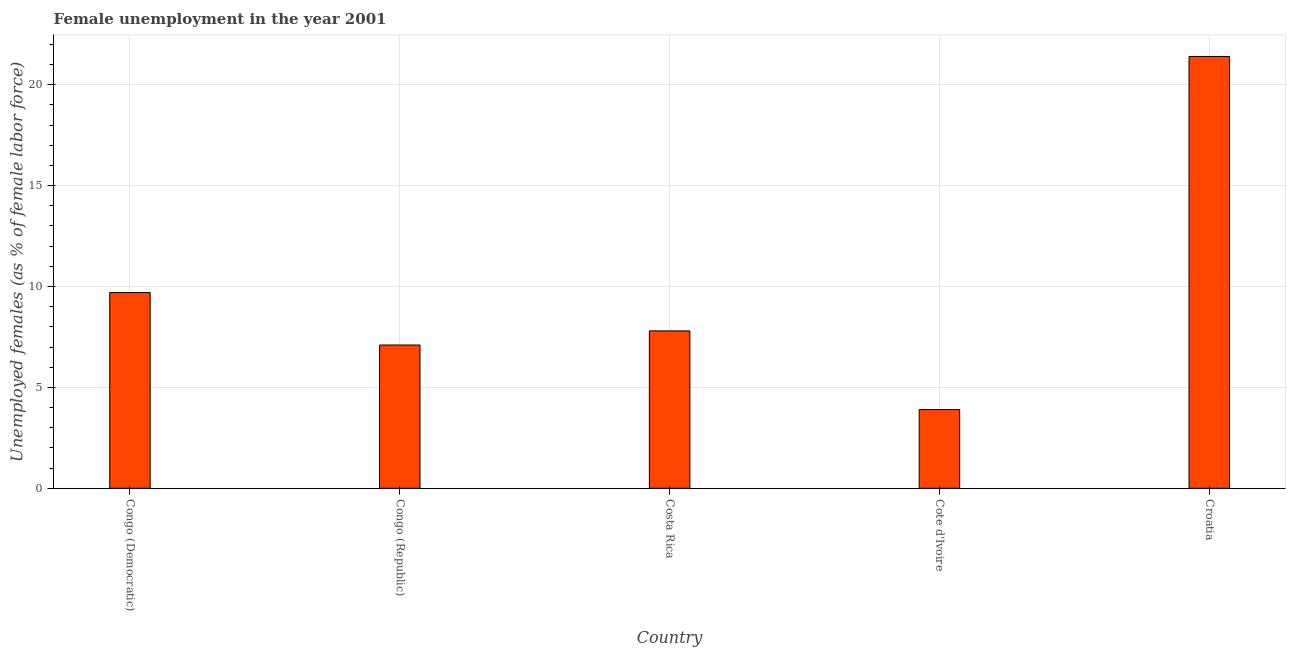What is the title of the graph?
Offer a terse response. Female unemployment in the year 2001. What is the label or title of the Y-axis?
Provide a short and direct response. Unemployed females (as % of female labor force). What is the unemployed females population in Cote d'Ivoire?
Provide a short and direct response. 3.9. Across all countries, what is the maximum unemployed females population?
Your response must be concise. 21.4. Across all countries, what is the minimum unemployed females population?
Your answer should be compact. 3.9. In which country was the unemployed females population maximum?
Offer a very short reply. Croatia. In which country was the unemployed females population minimum?
Ensure brevity in your answer.  Cote d'Ivoire. What is the sum of the unemployed females population?
Your answer should be compact. 49.9. What is the average unemployed females population per country?
Ensure brevity in your answer.  9.98. What is the median unemployed females population?
Your response must be concise. 7.8. In how many countries, is the unemployed females population greater than 14 %?
Make the answer very short. 1. What is the ratio of the unemployed females population in Congo (Republic) to that in Cote d'Ivoire?
Your answer should be very brief. 1.82. Is the unemployed females population in Congo (Democratic) less than that in Cote d'Ivoire?
Keep it short and to the point. No. Is the sum of the unemployed females population in Congo (Republic) and Costa Rica greater than the maximum unemployed females population across all countries?
Keep it short and to the point. No. How many bars are there?
Provide a succinct answer. 5. Are all the bars in the graph horizontal?
Your answer should be very brief. No. Are the values on the major ticks of Y-axis written in scientific E-notation?
Offer a very short reply. No. What is the Unemployed females (as % of female labor force) of Congo (Democratic)?
Provide a short and direct response. 9.7. What is the Unemployed females (as % of female labor force) of Congo (Republic)?
Provide a short and direct response. 7.1. What is the Unemployed females (as % of female labor force) in Costa Rica?
Your response must be concise. 7.8. What is the Unemployed females (as % of female labor force) in Cote d'Ivoire?
Your response must be concise. 3.9. What is the Unemployed females (as % of female labor force) in Croatia?
Offer a terse response. 21.4. What is the difference between the Unemployed females (as % of female labor force) in Congo (Democratic) and Congo (Republic)?
Make the answer very short. 2.6. What is the difference between the Unemployed females (as % of female labor force) in Congo (Democratic) and Croatia?
Provide a short and direct response. -11.7. What is the difference between the Unemployed females (as % of female labor force) in Congo (Republic) and Costa Rica?
Keep it short and to the point. -0.7. What is the difference between the Unemployed females (as % of female labor force) in Congo (Republic) and Cote d'Ivoire?
Make the answer very short. 3.2. What is the difference between the Unemployed females (as % of female labor force) in Congo (Republic) and Croatia?
Keep it short and to the point. -14.3. What is the difference between the Unemployed females (as % of female labor force) in Cote d'Ivoire and Croatia?
Your response must be concise. -17.5. What is the ratio of the Unemployed females (as % of female labor force) in Congo (Democratic) to that in Congo (Republic)?
Provide a succinct answer. 1.37. What is the ratio of the Unemployed females (as % of female labor force) in Congo (Democratic) to that in Costa Rica?
Ensure brevity in your answer.  1.24. What is the ratio of the Unemployed females (as % of female labor force) in Congo (Democratic) to that in Cote d'Ivoire?
Keep it short and to the point. 2.49. What is the ratio of the Unemployed females (as % of female labor force) in Congo (Democratic) to that in Croatia?
Ensure brevity in your answer.  0.45. What is the ratio of the Unemployed females (as % of female labor force) in Congo (Republic) to that in Costa Rica?
Offer a very short reply. 0.91. What is the ratio of the Unemployed females (as % of female labor force) in Congo (Republic) to that in Cote d'Ivoire?
Your answer should be compact. 1.82. What is the ratio of the Unemployed females (as % of female labor force) in Congo (Republic) to that in Croatia?
Offer a very short reply. 0.33. What is the ratio of the Unemployed females (as % of female labor force) in Costa Rica to that in Croatia?
Your answer should be compact. 0.36. What is the ratio of the Unemployed females (as % of female labor force) in Cote d'Ivoire to that in Croatia?
Provide a short and direct response. 0.18. 